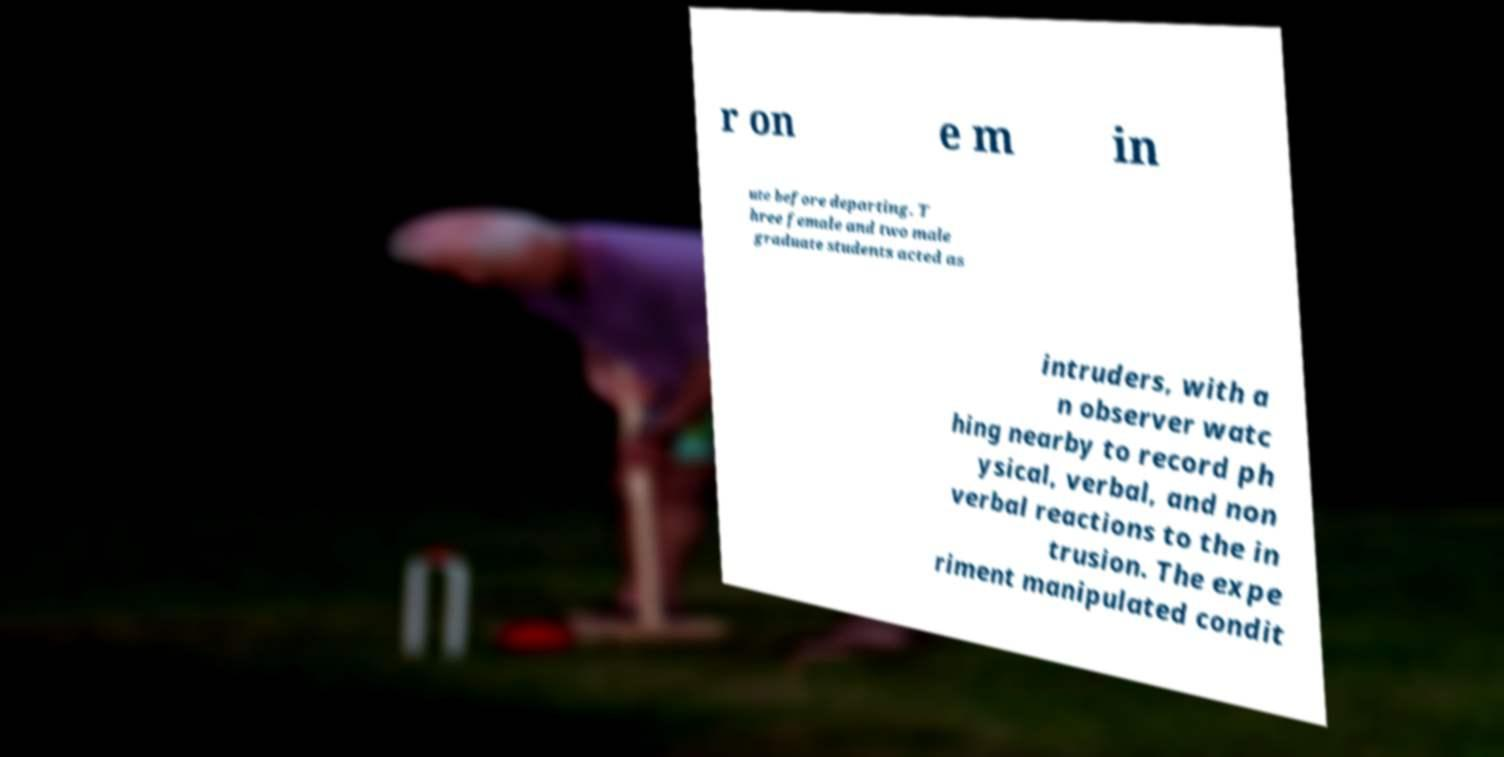There's text embedded in this image that I need extracted. Can you transcribe it verbatim? r on e m in ute before departing. T hree female and two male graduate students acted as intruders, with a n observer watc hing nearby to record ph ysical, verbal, and non verbal reactions to the in trusion. The expe riment manipulated condit 